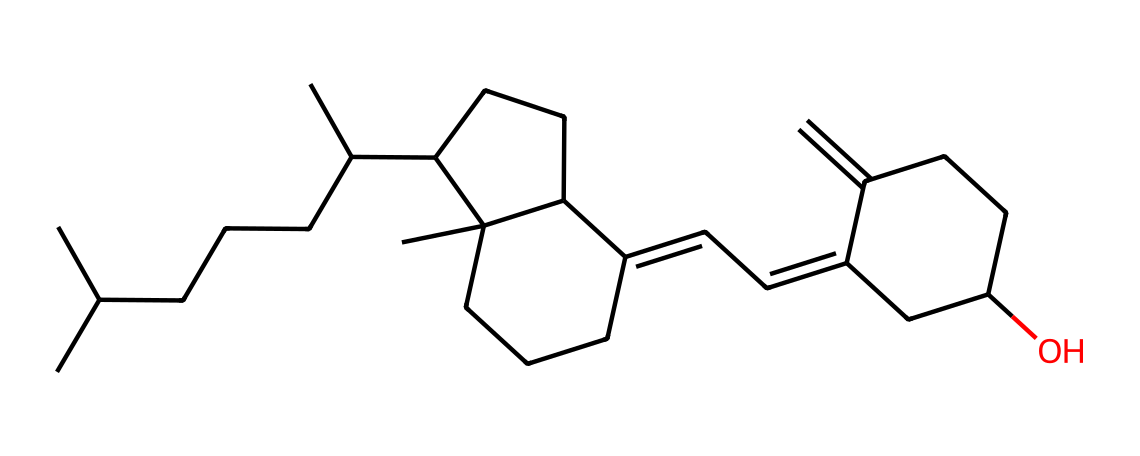what is the name of this chemical? The chemical represented by the SMILES is vitamin D, which can also be specifically referred to as cholecalciferol when synthesized in the skin during sun exposure.
Answer: vitamin D how many carbon atoms are in this structure? By analyzing the structure and counting the carbon symbols in the SMILES representation, we find there are 27 carbon atoms in total.
Answer: 27 does this chemical have any functional groups? Upon examining the structure, we can identify a hydroxyl group (-OH) as the only functional group present in the vitamin D structure, indicating its alcohol classification.
Answer: hydroxyl group what type of molecule is this? The overall structure is characteristic of a steroid due to the presence of multiple fused ring systems and a long hydrocarbon tail, which are typical features of steroid molecules.
Answer: steroid what kind of solubility properties does this chemical exhibit? Given the lipophilic nature with a long hydrocarbon tail, this molecule primarily demonstrates fat solubility rather than water solubility.
Answer: fat-soluble how many rings are in the structure? By examining the structure, there are four interconnected rings in the molecular framework, which is a defining characteristic of steroid-like structures.
Answer: four what is the significance of the hydroxyl group in this chemical? The presence of the hydroxyl group contributes to the biological activity of vitamin D, enabling it to interact with vitamin D receptors in the body for calcium metabolism regulation.
Answer: biological activity 